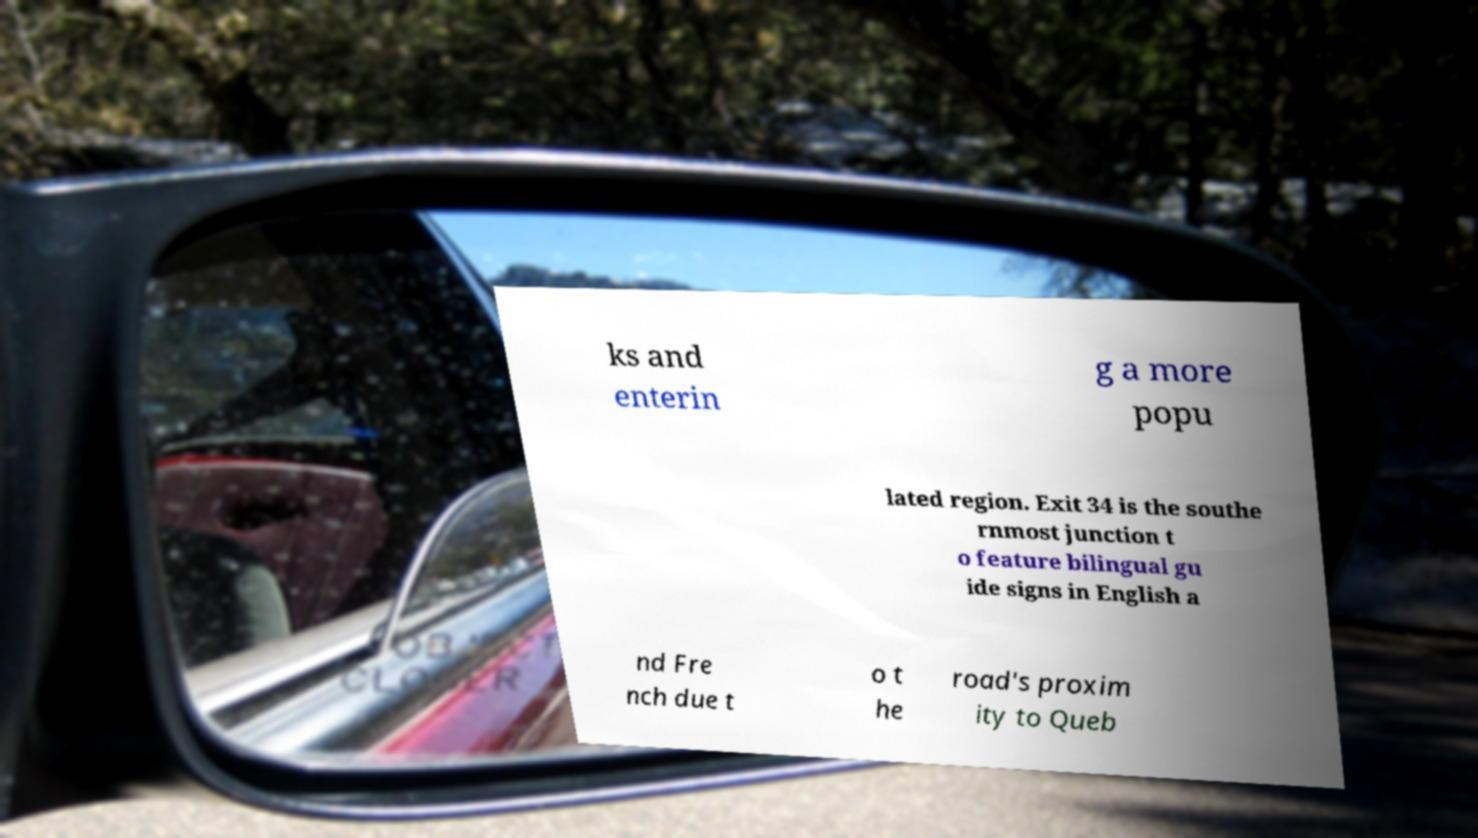There's text embedded in this image that I need extracted. Can you transcribe it verbatim? ks and enterin g a more popu lated region. Exit 34 is the southe rnmost junction t o feature bilingual gu ide signs in English a nd Fre nch due t o t he road's proxim ity to Queb 